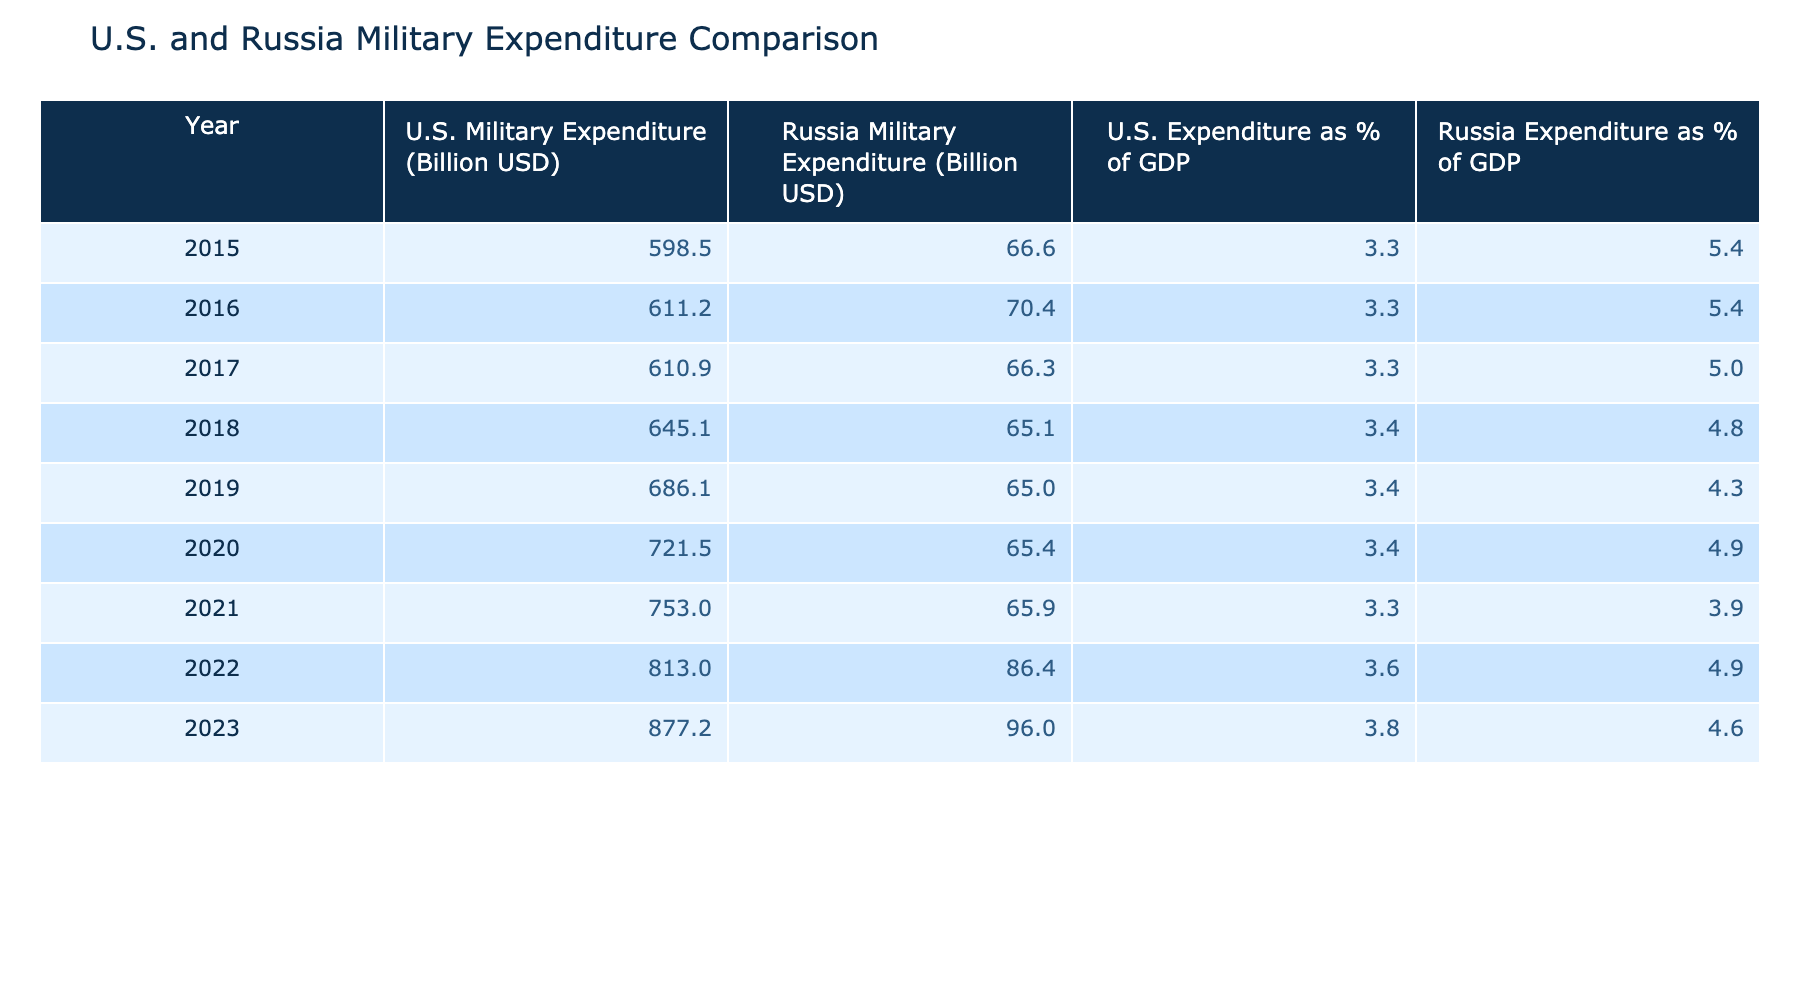What was the U.S. military expenditure in 2020? Referring to the table, the U.S. military expenditure for the year 2020 is listed as 721.5 billion USD.
Answer: 721.5 billion USD What was the trend in Russia's military expenditure from 2015 to 2023? By reviewing the table, Russia's military expenditure increased from 66.6 billion USD in 2015 to 96.0 billion USD in 2023. This indicates a consistent upward trend over the years.
Answer: Increasing trend What is the average U.S. military expenditure from 2015 to 2023? To find the average, sum the expenditures: 598.5 + 611.2 + 610.9 + 645.1 + 686.1 + 721.5 + 753.0 + 813.0 + 877.2 =  4810.5 billion USD. There are 9 data points, so the average is 4810.5 / 9 ≈ 534.5 billion USD.
Answer: 534.5 billion USD Did Russia spend more on military expenditure than the U.S. in 2016? Looking at the table for 2016, the U.S. expenditure was 611.2 billion USD while Russia's was 70.4 billion USD. Since 611.2 is greater than 70.4, the statement is false.
Answer: No What was the difference between the U.S. and Russia military expenditures in 2022? From the table, the U.S. expenditure in 2022 was 813.0 billion USD and Russia's was 86.4 billion USD. The difference is 813.0 - 86.4 = 726.6 billion USD.
Answer: 726.6 billion USD What percentage of GDP was accounted for by U.S. military expenditure in 2023? The table specifies that the U.S. military expenditure as a percentage of GDP for 2023 is 3.8%. Thus, the answer is directly available in the table.
Answer: 3.8% Was there a year in which the U.S. military expenditure exceeded 800 billion USD? According to the table, the U.S. military expenditure was above 800 billion USD in 2022 and 2023 (813.0 and 877.2 billion USD, respectively). Therefore, the statement is true.
Answer: Yes If we compare the expenditures in 2015 and 2023 for both countries, which country had a greater absolute increase? In 2015, the U.S. expenditure was 598.5 billion USD, and in 2023, it was 877.2 billion USD. The increase is 877.2 - 598.5 = 278.7 billion USD. For Russia, from 66.6 billion USD in 2015 to 96.0 billion USD in 2023, the increase is 96.0 - 66.6 = 29.4 billion USD. Comparing increases (278.7 > 29.4), the U.S. had a greater increase.
Answer: U.S. had a greater increase What was the maximum percentage of GDP for Russia's military expenditure in the years provided? By examining the table, the maximum percentage of GDP for Russia's military expenditure is 5.4%, which occurred in both 2015 and 2016.
Answer: 5.4% 